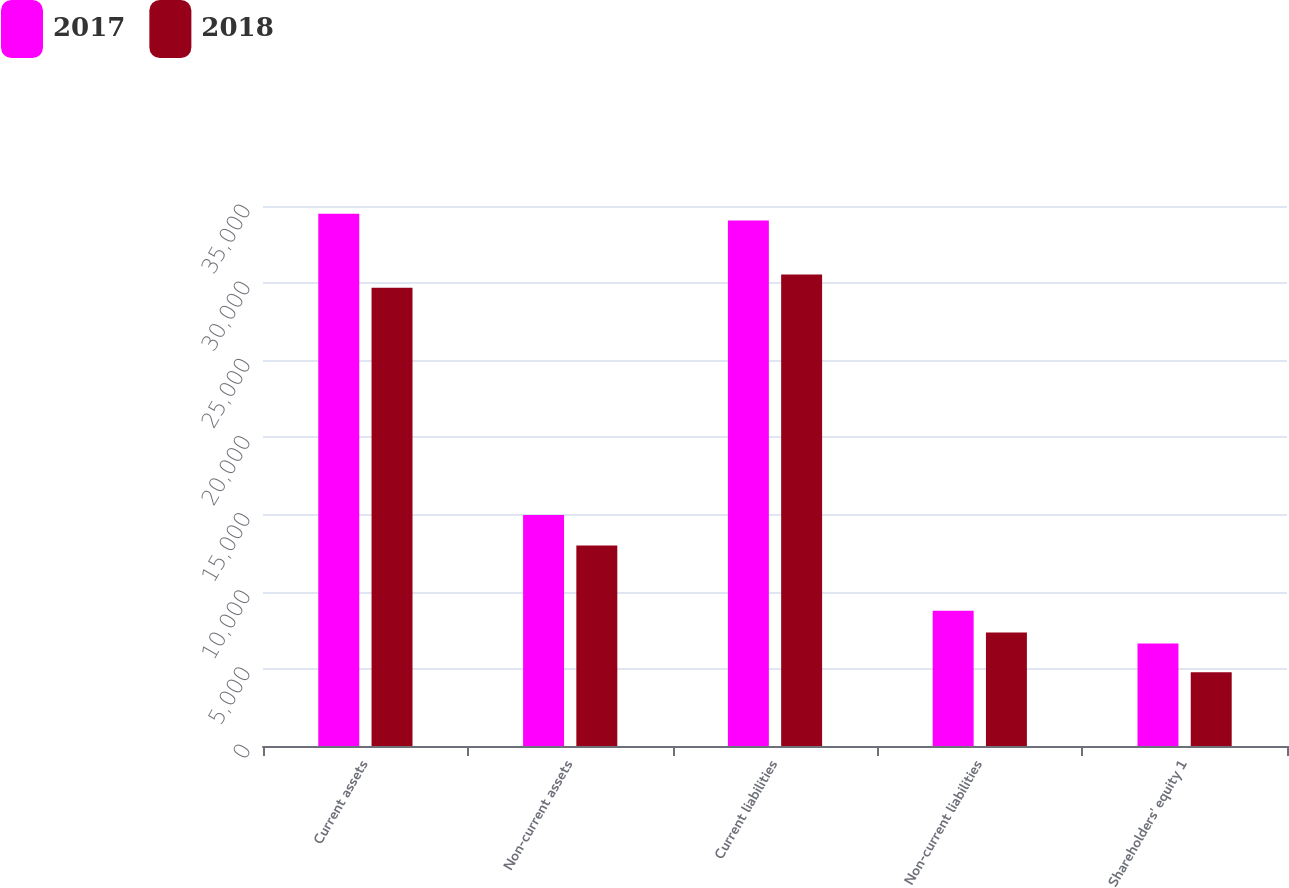<chart> <loc_0><loc_0><loc_500><loc_500><stacked_bar_chart><ecel><fcel>Current assets<fcel>Non-current assets<fcel>Current liabilities<fcel>Non-current liabilities<fcel>Shareholders' equity 1<nl><fcel>2017<fcel>34493<fcel>14971<fcel>34055<fcel>8759<fcel>6650<nl><fcel>2018<fcel>29707<fcel>12999<fcel>30559<fcel>7362<fcel>4785<nl></chart> 